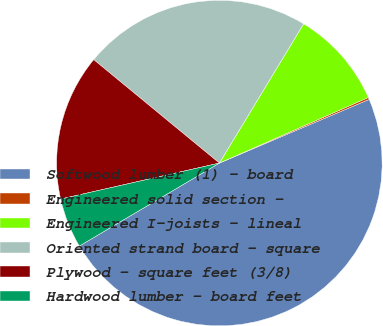Convert chart to OTSL. <chart><loc_0><loc_0><loc_500><loc_500><pie_chart><fcel>Softwood lumber (1) - board<fcel>Engineered solid section -<fcel>Engineered I-joists - lineal<fcel>Oriented strand board - square<fcel>Plywood - square feet (3/8)<fcel>Hardwood lumber - board feet<nl><fcel>47.89%<fcel>0.2%<fcel>9.74%<fcel>22.7%<fcel>14.51%<fcel>4.97%<nl></chart> 